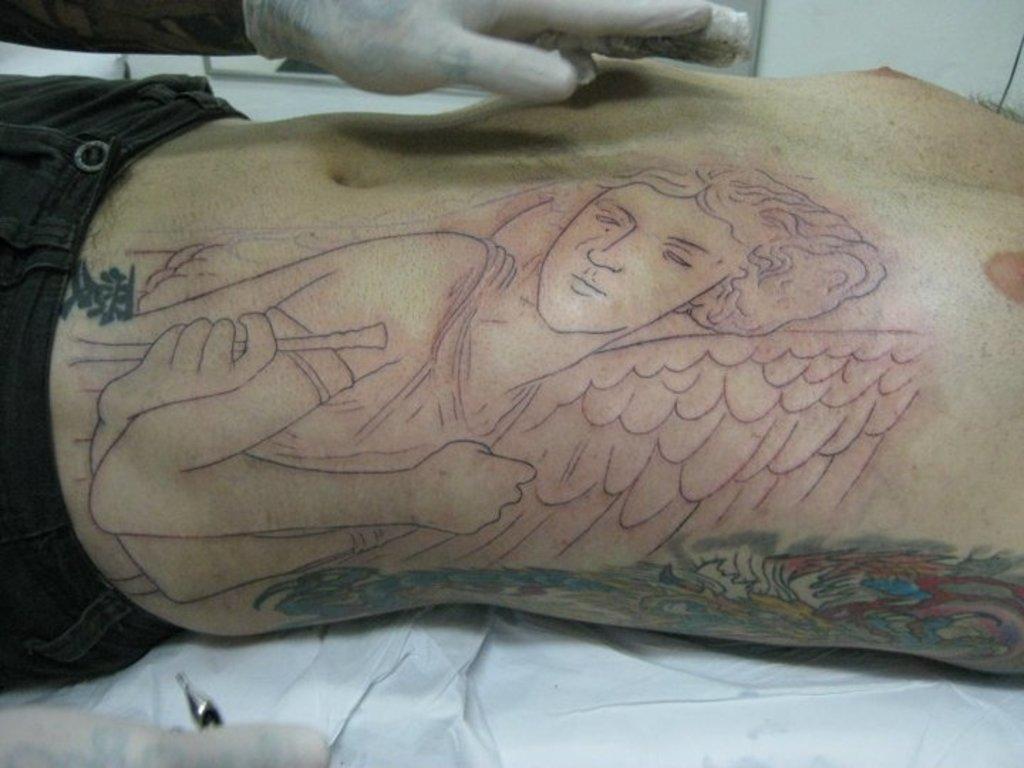How would you summarize this image in a sentence or two? In this picture I can see a man, who is lying and I can see tattoos on his body and I can see a person's hand on the top of this picture. 